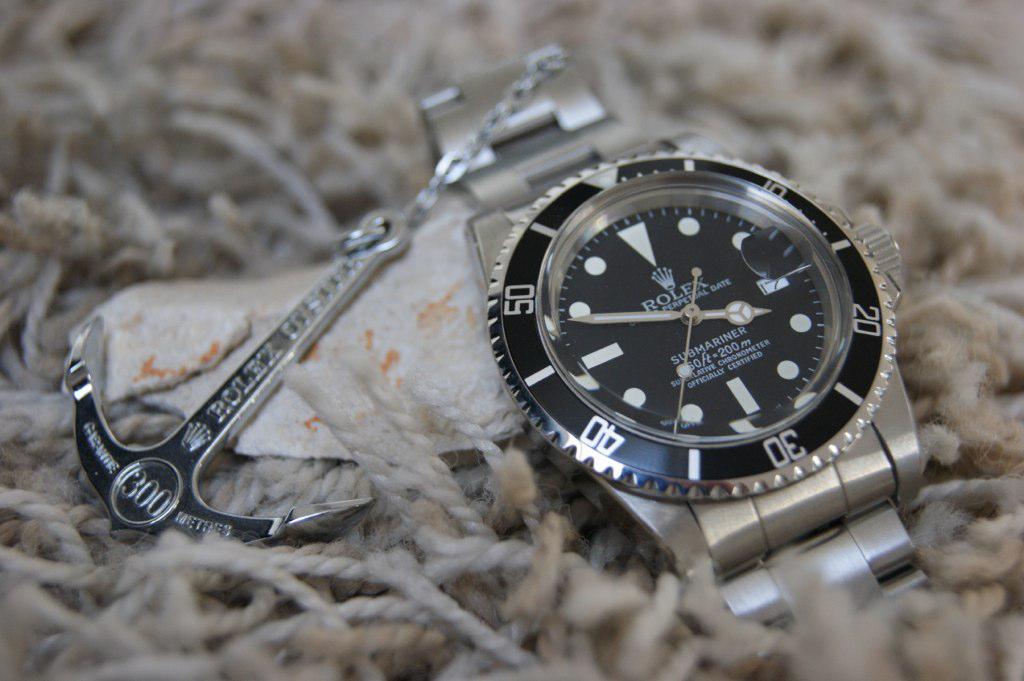What company makes the watch?
Give a very brief answer. Rolex. 